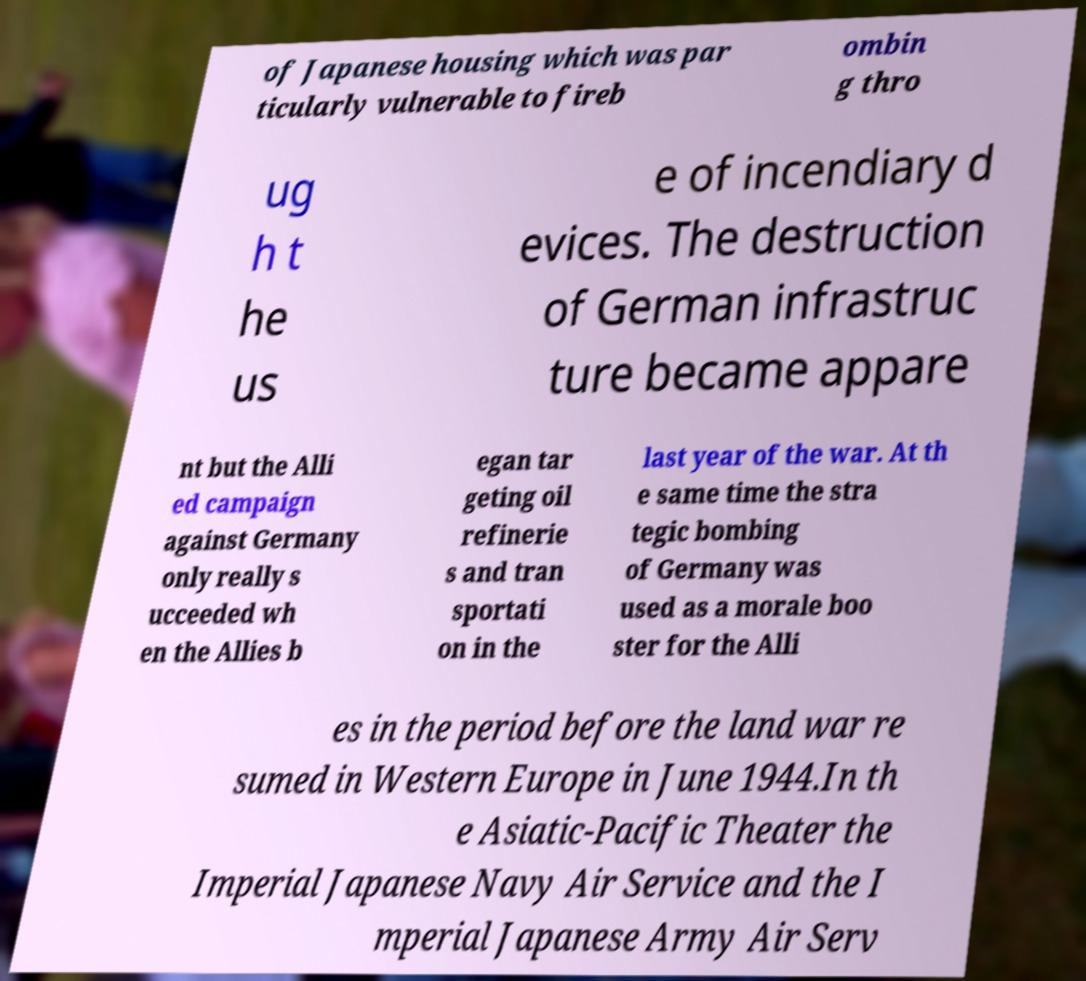Could you extract and type out the text from this image? of Japanese housing which was par ticularly vulnerable to fireb ombin g thro ug h t he us e of incendiary d evices. The destruction of German infrastruc ture became appare nt but the Alli ed campaign against Germany only really s ucceeded wh en the Allies b egan tar geting oil refinerie s and tran sportati on in the last year of the war. At th e same time the stra tegic bombing of Germany was used as a morale boo ster for the Alli es in the period before the land war re sumed in Western Europe in June 1944.In th e Asiatic-Pacific Theater the Imperial Japanese Navy Air Service and the I mperial Japanese Army Air Serv 